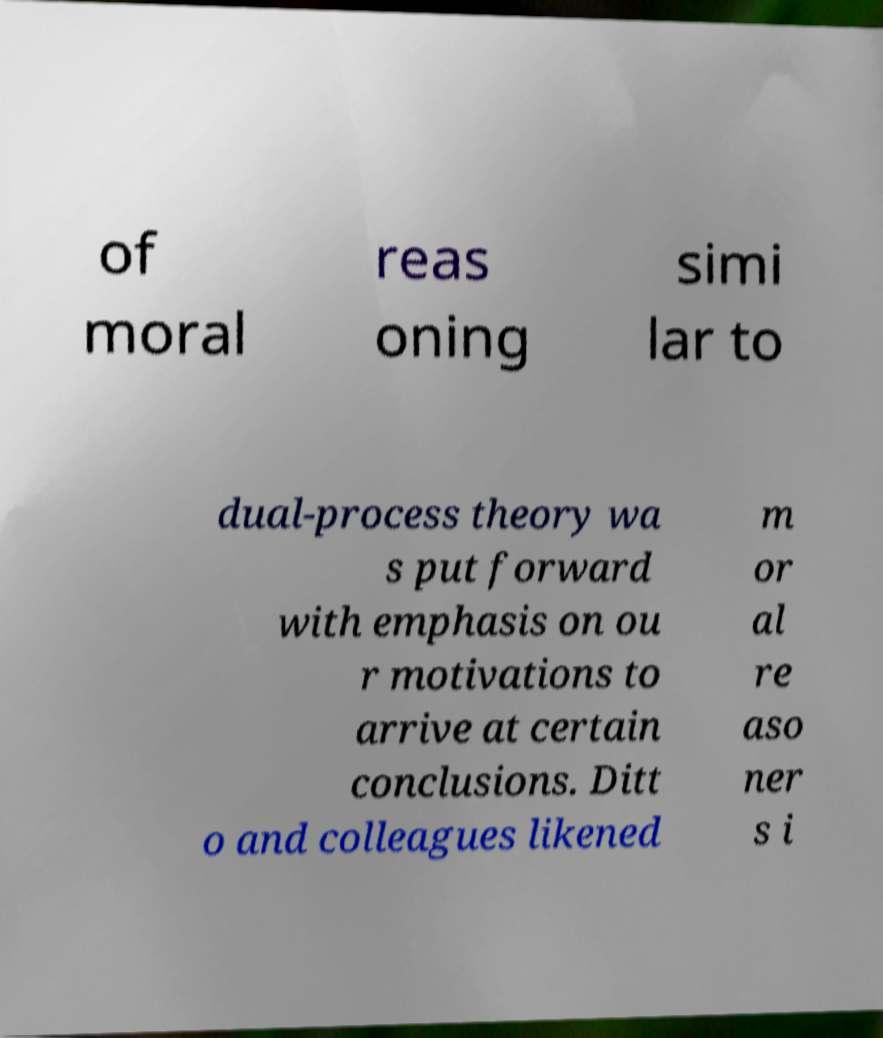There's text embedded in this image that I need extracted. Can you transcribe it verbatim? of moral reas oning simi lar to dual-process theory wa s put forward with emphasis on ou r motivations to arrive at certain conclusions. Ditt o and colleagues likened m or al re aso ner s i 